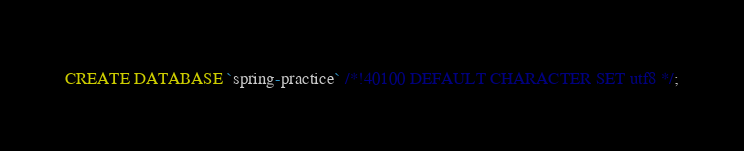<code> <loc_0><loc_0><loc_500><loc_500><_SQL_>CREATE DATABASE `spring-practice` /*!40100 DEFAULT CHARACTER SET utf8 */;
</code> 